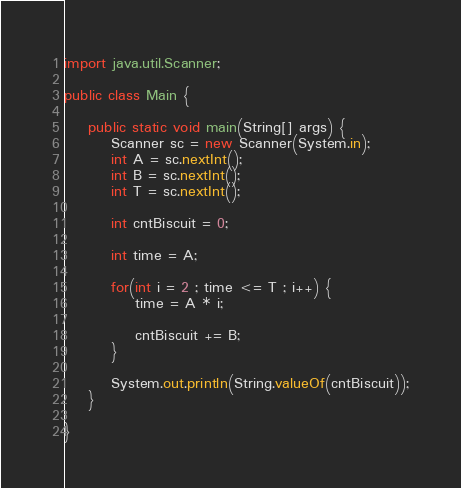<code> <loc_0><loc_0><loc_500><loc_500><_Java_>import java.util.Scanner;

public class Main {

	public static void main(String[] args) {
		Scanner sc = new Scanner(System.in);
        int A = sc.nextInt();
        int B = sc.nextInt();
        int T = sc.nextInt();

        int cntBiscuit = 0;

        int time = A;

        for(int i = 2 ; time <= T ; i++) {
        	time = A * i;

        	cntBiscuit += B;
        }

        System.out.println(String.valueOf(cntBiscuit));
	}

}</code> 